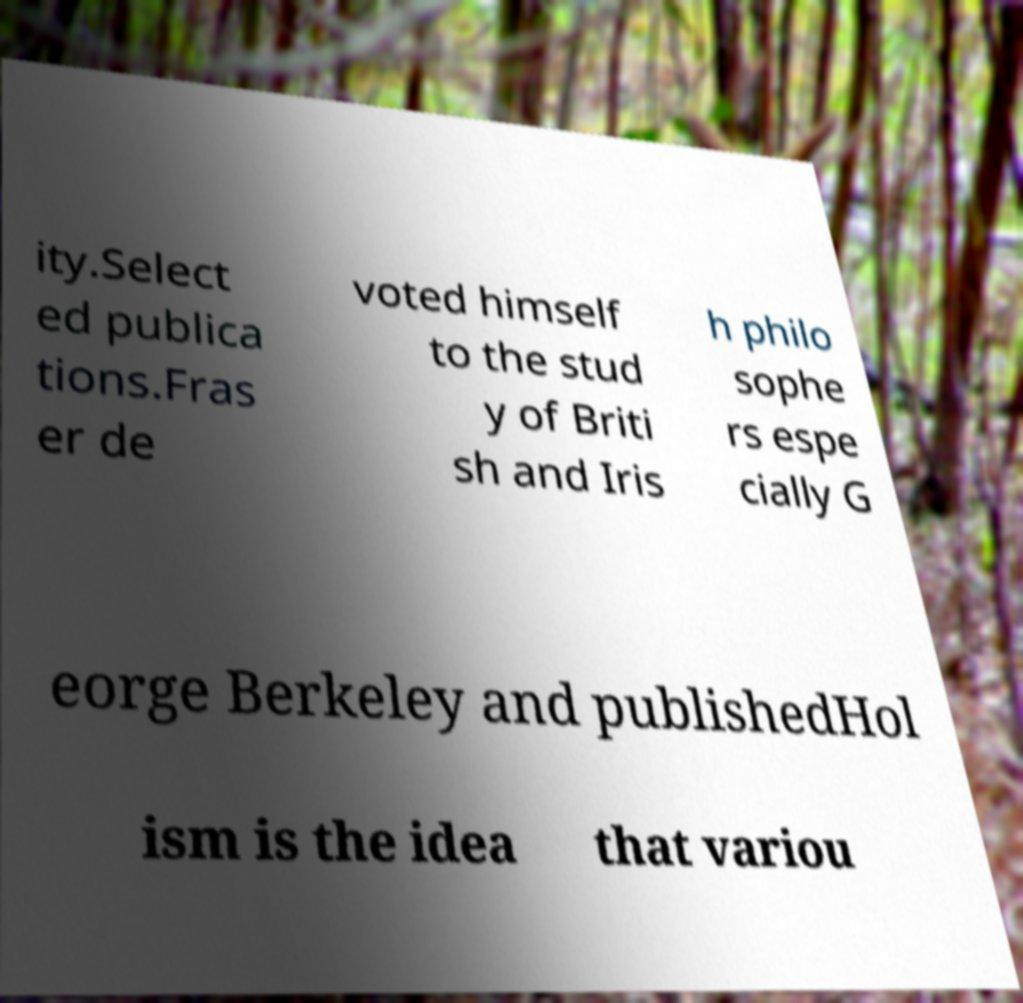Could you assist in decoding the text presented in this image and type it out clearly? ity.Select ed publica tions.Fras er de voted himself to the stud y of Briti sh and Iris h philo sophe rs espe cially G eorge Berkeley and publishedHol ism is the idea that variou 